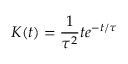<formula> <loc_0><loc_0><loc_500><loc_500>K ( t ) = \frac { 1 } { \tau ^ { 2 } } t e ^ { - t / \tau }</formula> 